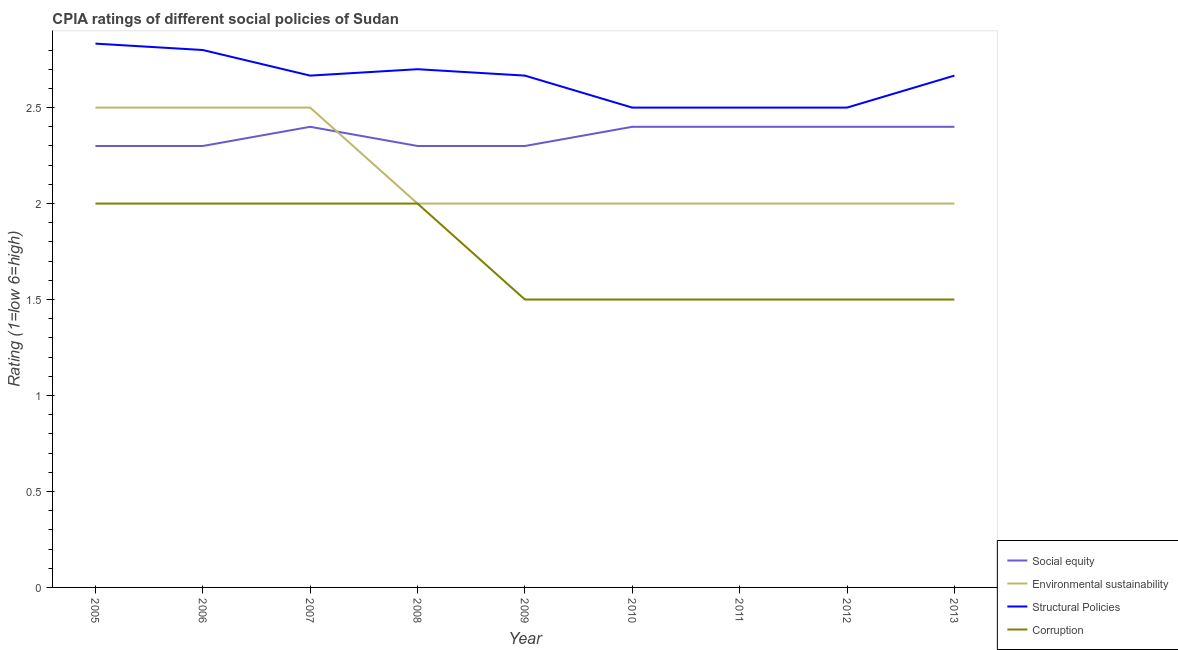How many different coloured lines are there?
Give a very brief answer. 4. What is the cpia rating of social equity in 2010?
Provide a short and direct response. 2.4. Across all years, what is the maximum cpia rating of structural policies?
Give a very brief answer. 2.83. In which year was the cpia rating of social equity maximum?
Make the answer very short. 2007. What is the total cpia rating of structural policies in the graph?
Keep it short and to the point. 23.83. What is the difference between the cpia rating of structural policies in 2007 and that in 2013?
Ensure brevity in your answer.  0. What is the difference between the cpia rating of corruption in 2009 and the cpia rating of environmental sustainability in 2013?
Offer a terse response. -0.5. What is the average cpia rating of structural policies per year?
Make the answer very short. 2.65. In the year 2010, what is the difference between the cpia rating of environmental sustainability and cpia rating of corruption?
Offer a very short reply. 0.5. What is the ratio of the cpia rating of social equity in 2007 to that in 2009?
Provide a succinct answer. 1.04. Is the difference between the cpia rating of corruption in 2011 and 2012 greater than the difference between the cpia rating of social equity in 2011 and 2012?
Keep it short and to the point. No. What is the difference between the highest and the second highest cpia rating of structural policies?
Offer a terse response. 0.03. What is the difference between the highest and the lowest cpia rating of structural policies?
Your response must be concise. 0.33. Is it the case that in every year, the sum of the cpia rating of social equity and cpia rating of environmental sustainability is greater than the cpia rating of structural policies?
Offer a very short reply. Yes. Does the graph contain grids?
Your answer should be compact. No. Where does the legend appear in the graph?
Provide a succinct answer. Bottom right. How many legend labels are there?
Your answer should be very brief. 4. What is the title of the graph?
Offer a very short reply. CPIA ratings of different social policies of Sudan. What is the label or title of the X-axis?
Provide a succinct answer. Year. What is the Rating (1=low 6=high) of Social equity in 2005?
Keep it short and to the point. 2.3. What is the Rating (1=low 6=high) in Environmental sustainability in 2005?
Your answer should be compact. 2.5. What is the Rating (1=low 6=high) of Structural Policies in 2005?
Your answer should be compact. 2.83. What is the Rating (1=low 6=high) of Structural Policies in 2006?
Make the answer very short. 2.8. What is the Rating (1=low 6=high) of Environmental sustainability in 2007?
Give a very brief answer. 2.5. What is the Rating (1=low 6=high) of Structural Policies in 2007?
Offer a very short reply. 2.67. What is the Rating (1=low 6=high) of Social equity in 2009?
Offer a terse response. 2.3. What is the Rating (1=low 6=high) in Structural Policies in 2009?
Your answer should be compact. 2.67. What is the Rating (1=low 6=high) in Social equity in 2010?
Provide a succinct answer. 2.4. What is the Rating (1=low 6=high) of Environmental sustainability in 2010?
Your answer should be compact. 2. What is the Rating (1=low 6=high) of Corruption in 2010?
Your answer should be compact. 1.5. What is the Rating (1=low 6=high) of Structural Policies in 2011?
Your answer should be very brief. 2.5. What is the Rating (1=low 6=high) of Corruption in 2011?
Make the answer very short. 1.5. What is the Rating (1=low 6=high) in Environmental sustainability in 2012?
Offer a terse response. 2. What is the Rating (1=low 6=high) of Structural Policies in 2012?
Your answer should be very brief. 2.5. What is the Rating (1=low 6=high) of Social equity in 2013?
Give a very brief answer. 2.4. What is the Rating (1=low 6=high) of Structural Policies in 2013?
Provide a succinct answer. 2.67. Across all years, what is the maximum Rating (1=low 6=high) in Structural Policies?
Make the answer very short. 2.83. Across all years, what is the maximum Rating (1=low 6=high) in Corruption?
Keep it short and to the point. 2. Across all years, what is the minimum Rating (1=low 6=high) of Social equity?
Offer a terse response. 2.3. Across all years, what is the minimum Rating (1=low 6=high) in Corruption?
Offer a terse response. 1.5. What is the total Rating (1=low 6=high) in Social equity in the graph?
Provide a short and direct response. 21.2. What is the total Rating (1=low 6=high) of Environmental sustainability in the graph?
Give a very brief answer. 19.5. What is the total Rating (1=low 6=high) in Structural Policies in the graph?
Make the answer very short. 23.83. What is the difference between the Rating (1=low 6=high) of Social equity in 2005 and that in 2006?
Your answer should be very brief. 0. What is the difference between the Rating (1=low 6=high) of Structural Policies in 2005 and that in 2006?
Your answer should be very brief. 0.03. What is the difference between the Rating (1=low 6=high) of Corruption in 2005 and that in 2006?
Give a very brief answer. 0. What is the difference between the Rating (1=low 6=high) in Structural Policies in 2005 and that in 2007?
Your answer should be very brief. 0.17. What is the difference between the Rating (1=low 6=high) of Social equity in 2005 and that in 2008?
Your answer should be compact. 0. What is the difference between the Rating (1=low 6=high) of Environmental sustainability in 2005 and that in 2008?
Give a very brief answer. 0.5. What is the difference between the Rating (1=low 6=high) in Structural Policies in 2005 and that in 2008?
Your response must be concise. 0.13. What is the difference between the Rating (1=low 6=high) of Social equity in 2005 and that in 2009?
Provide a short and direct response. 0. What is the difference between the Rating (1=low 6=high) in Social equity in 2005 and that in 2010?
Make the answer very short. -0.1. What is the difference between the Rating (1=low 6=high) of Structural Policies in 2005 and that in 2010?
Your response must be concise. 0.33. What is the difference between the Rating (1=low 6=high) of Corruption in 2005 and that in 2010?
Ensure brevity in your answer.  0.5. What is the difference between the Rating (1=low 6=high) in Corruption in 2005 and that in 2011?
Ensure brevity in your answer.  0.5. What is the difference between the Rating (1=low 6=high) of Corruption in 2005 and that in 2012?
Give a very brief answer. 0.5. What is the difference between the Rating (1=low 6=high) in Social equity in 2005 and that in 2013?
Your answer should be very brief. -0.1. What is the difference between the Rating (1=low 6=high) in Corruption in 2005 and that in 2013?
Your answer should be compact. 0.5. What is the difference between the Rating (1=low 6=high) in Social equity in 2006 and that in 2007?
Ensure brevity in your answer.  -0.1. What is the difference between the Rating (1=low 6=high) in Structural Policies in 2006 and that in 2007?
Your answer should be very brief. 0.13. What is the difference between the Rating (1=low 6=high) in Corruption in 2006 and that in 2007?
Offer a very short reply. 0. What is the difference between the Rating (1=low 6=high) of Social equity in 2006 and that in 2008?
Your answer should be compact. 0. What is the difference between the Rating (1=low 6=high) in Environmental sustainability in 2006 and that in 2008?
Your answer should be very brief. 0.5. What is the difference between the Rating (1=low 6=high) of Structural Policies in 2006 and that in 2008?
Offer a terse response. 0.1. What is the difference between the Rating (1=low 6=high) of Corruption in 2006 and that in 2008?
Your response must be concise. 0. What is the difference between the Rating (1=low 6=high) in Structural Policies in 2006 and that in 2009?
Your answer should be very brief. 0.13. What is the difference between the Rating (1=low 6=high) of Structural Policies in 2006 and that in 2012?
Provide a short and direct response. 0.3. What is the difference between the Rating (1=low 6=high) of Corruption in 2006 and that in 2012?
Ensure brevity in your answer.  0.5. What is the difference between the Rating (1=low 6=high) of Social equity in 2006 and that in 2013?
Provide a short and direct response. -0.1. What is the difference between the Rating (1=low 6=high) in Environmental sustainability in 2006 and that in 2013?
Offer a very short reply. 0.5. What is the difference between the Rating (1=low 6=high) in Structural Policies in 2006 and that in 2013?
Your response must be concise. 0.13. What is the difference between the Rating (1=low 6=high) in Corruption in 2006 and that in 2013?
Offer a very short reply. 0.5. What is the difference between the Rating (1=low 6=high) of Social equity in 2007 and that in 2008?
Offer a very short reply. 0.1. What is the difference between the Rating (1=low 6=high) in Structural Policies in 2007 and that in 2008?
Your response must be concise. -0.03. What is the difference between the Rating (1=low 6=high) of Corruption in 2007 and that in 2008?
Make the answer very short. 0. What is the difference between the Rating (1=low 6=high) in Social equity in 2007 and that in 2009?
Keep it short and to the point. 0.1. What is the difference between the Rating (1=low 6=high) of Environmental sustainability in 2007 and that in 2009?
Offer a very short reply. 0.5. What is the difference between the Rating (1=low 6=high) of Structural Policies in 2007 and that in 2009?
Offer a very short reply. 0. What is the difference between the Rating (1=low 6=high) of Social equity in 2007 and that in 2010?
Give a very brief answer. 0. What is the difference between the Rating (1=low 6=high) of Corruption in 2007 and that in 2010?
Make the answer very short. 0.5. What is the difference between the Rating (1=low 6=high) of Corruption in 2007 and that in 2012?
Keep it short and to the point. 0.5. What is the difference between the Rating (1=low 6=high) of Structural Policies in 2007 and that in 2013?
Offer a terse response. 0. What is the difference between the Rating (1=low 6=high) in Corruption in 2007 and that in 2013?
Offer a terse response. 0.5. What is the difference between the Rating (1=low 6=high) of Environmental sustainability in 2008 and that in 2009?
Your answer should be compact. 0. What is the difference between the Rating (1=low 6=high) in Corruption in 2008 and that in 2009?
Keep it short and to the point. 0.5. What is the difference between the Rating (1=low 6=high) of Social equity in 2008 and that in 2010?
Provide a succinct answer. -0.1. What is the difference between the Rating (1=low 6=high) of Structural Policies in 2008 and that in 2010?
Offer a terse response. 0.2. What is the difference between the Rating (1=low 6=high) in Corruption in 2008 and that in 2010?
Make the answer very short. 0.5. What is the difference between the Rating (1=low 6=high) in Social equity in 2008 and that in 2011?
Offer a very short reply. -0.1. What is the difference between the Rating (1=low 6=high) of Social equity in 2008 and that in 2012?
Your answer should be very brief. -0.1. What is the difference between the Rating (1=low 6=high) in Environmental sustainability in 2008 and that in 2012?
Your response must be concise. 0. What is the difference between the Rating (1=low 6=high) of Structural Policies in 2008 and that in 2012?
Your response must be concise. 0.2. What is the difference between the Rating (1=low 6=high) of Corruption in 2008 and that in 2012?
Your response must be concise. 0.5. What is the difference between the Rating (1=low 6=high) in Environmental sustainability in 2008 and that in 2013?
Your response must be concise. 0. What is the difference between the Rating (1=low 6=high) in Social equity in 2009 and that in 2010?
Give a very brief answer. -0.1. What is the difference between the Rating (1=low 6=high) in Social equity in 2009 and that in 2011?
Give a very brief answer. -0.1. What is the difference between the Rating (1=low 6=high) in Corruption in 2009 and that in 2011?
Your answer should be compact. 0. What is the difference between the Rating (1=low 6=high) of Environmental sustainability in 2009 and that in 2012?
Make the answer very short. 0. What is the difference between the Rating (1=low 6=high) of Corruption in 2009 and that in 2012?
Offer a very short reply. 0. What is the difference between the Rating (1=low 6=high) in Social equity in 2009 and that in 2013?
Your answer should be very brief. -0.1. What is the difference between the Rating (1=low 6=high) of Environmental sustainability in 2009 and that in 2013?
Keep it short and to the point. 0. What is the difference between the Rating (1=low 6=high) of Structural Policies in 2009 and that in 2013?
Keep it short and to the point. 0. What is the difference between the Rating (1=low 6=high) in Environmental sustainability in 2010 and that in 2011?
Make the answer very short. 0. What is the difference between the Rating (1=low 6=high) in Social equity in 2010 and that in 2012?
Provide a succinct answer. 0. What is the difference between the Rating (1=low 6=high) of Structural Policies in 2010 and that in 2012?
Offer a very short reply. 0. What is the difference between the Rating (1=low 6=high) of Structural Policies in 2010 and that in 2013?
Give a very brief answer. -0.17. What is the difference between the Rating (1=low 6=high) of Corruption in 2011 and that in 2012?
Keep it short and to the point. 0. What is the difference between the Rating (1=low 6=high) of Environmental sustainability in 2011 and that in 2013?
Your answer should be very brief. 0. What is the difference between the Rating (1=low 6=high) in Environmental sustainability in 2012 and that in 2013?
Offer a terse response. 0. What is the difference between the Rating (1=low 6=high) of Corruption in 2012 and that in 2013?
Offer a terse response. 0. What is the difference between the Rating (1=low 6=high) of Social equity in 2005 and the Rating (1=low 6=high) of Environmental sustainability in 2006?
Give a very brief answer. -0.2. What is the difference between the Rating (1=low 6=high) of Social equity in 2005 and the Rating (1=low 6=high) of Structural Policies in 2006?
Ensure brevity in your answer.  -0.5. What is the difference between the Rating (1=low 6=high) of Social equity in 2005 and the Rating (1=low 6=high) of Corruption in 2006?
Make the answer very short. 0.3. What is the difference between the Rating (1=low 6=high) of Environmental sustainability in 2005 and the Rating (1=low 6=high) of Structural Policies in 2006?
Your response must be concise. -0.3. What is the difference between the Rating (1=low 6=high) in Environmental sustainability in 2005 and the Rating (1=low 6=high) in Corruption in 2006?
Provide a short and direct response. 0.5. What is the difference between the Rating (1=low 6=high) in Social equity in 2005 and the Rating (1=low 6=high) in Structural Policies in 2007?
Offer a very short reply. -0.37. What is the difference between the Rating (1=low 6=high) in Social equity in 2005 and the Rating (1=low 6=high) in Corruption in 2007?
Offer a very short reply. 0.3. What is the difference between the Rating (1=low 6=high) of Structural Policies in 2005 and the Rating (1=low 6=high) of Corruption in 2007?
Give a very brief answer. 0.83. What is the difference between the Rating (1=low 6=high) of Social equity in 2005 and the Rating (1=low 6=high) of Environmental sustainability in 2008?
Make the answer very short. 0.3. What is the difference between the Rating (1=low 6=high) of Social equity in 2005 and the Rating (1=low 6=high) of Structural Policies in 2008?
Give a very brief answer. -0.4. What is the difference between the Rating (1=low 6=high) of Environmental sustainability in 2005 and the Rating (1=low 6=high) of Structural Policies in 2008?
Keep it short and to the point. -0.2. What is the difference between the Rating (1=low 6=high) of Social equity in 2005 and the Rating (1=low 6=high) of Structural Policies in 2009?
Provide a succinct answer. -0.37. What is the difference between the Rating (1=low 6=high) of Environmental sustainability in 2005 and the Rating (1=low 6=high) of Structural Policies in 2009?
Give a very brief answer. -0.17. What is the difference between the Rating (1=low 6=high) in Structural Policies in 2005 and the Rating (1=low 6=high) in Corruption in 2009?
Your answer should be compact. 1.33. What is the difference between the Rating (1=low 6=high) of Social equity in 2005 and the Rating (1=low 6=high) of Environmental sustainability in 2010?
Offer a very short reply. 0.3. What is the difference between the Rating (1=low 6=high) of Social equity in 2005 and the Rating (1=low 6=high) of Structural Policies in 2010?
Offer a very short reply. -0.2. What is the difference between the Rating (1=low 6=high) of Social equity in 2005 and the Rating (1=low 6=high) of Corruption in 2010?
Offer a very short reply. 0.8. What is the difference between the Rating (1=low 6=high) of Environmental sustainability in 2005 and the Rating (1=low 6=high) of Structural Policies in 2010?
Offer a terse response. 0. What is the difference between the Rating (1=low 6=high) of Environmental sustainability in 2005 and the Rating (1=low 6=high) of Corruption in 2010?
Provide a succinct answer. 1. What is the difference between the Rating (1=low 6=high) in Structural Policies in 2005 and the Rating (1=low 6=high) in Corruption in 2010?
Your answer should be compact. 1.33. What is the difference between the Rating (1=low 6=high) in Social equity in 2005 and the Rating (1=low 6=high) in Environmental sustainability in 2011?
Offer a terse response. 0.3. What is the difference between the Rating (1=low 6=high) of Environmental sustainability in 2005 and the Rating (1=low 6=high) of Structural Policies in 2011?
Offer a terse response. 0. What is the difference between the Rating (1=low 6=high) in Social equity in 2005 and the Rating (1=low 6=high) in Structural Policies in 2012?
Make the answer very short. -0.2. What is the difference between the Rating (1=low 6=high) of Social equity in 2005 and the Rating (1=low 6=high) of Corruption in 2012?
Your response must be concise. 0.8. What is the difference between the Rating (1=low 6=high) of Environmental sustainability in 2005 and the Rating (1=low 6=high) of Corruption in 2012?
Your answer should be compact. 1. What is the difference between the Rating (1=low 6=high) of Social equity in 2005 and the Rating (1=low 6=high) of Structural Policies in 2013?
Make the answer very short. -0.37. What is the difference between the Rating (1=low 6=high) of Environmental sustainability in 2005 and the Rating (1=low 6=high) of Corruption in 2013?
Your answer should be very brief. 1. What is the difference between the Rating (1=low 6=high) of Structural Policies in 2005 and the Rating (1=low 6=high) of Corruption in 2013?
Your answer should be compact. 1.33. What is the difference between the Rating (1=low 6=high) of Social equity in 2006 and the Rating (1=low 6=high) of Environmental sustainability in 2007?
Your response must be concise. -0.2. What is the difference between the Rating (1=low 6=high) of Social equity in 2006 and the Rating (1=low 6=high) of Structural Policies in 2007?
Your response must be concise. -0.37. What is the difference between the Rating (1=low 6=high) of Social equity in 2006 and the Rating (1=low 6=high) of Corruption in 2007?
Offer a very short reply. 0.3. What is the difference between the Rating (1=low 6=high) in Structural Policies in 2006 and the Rating (1=low 6=high) in Corruption in 2007?
Make the answer very short. 0.8. What is the difference between the Rating (1=low 6=high) in Social equity in 2006 and the Rating (1=low 6=high) in Structural Policies in 2008?
Provide a short and direct response. -0.4. What is the difference between the Rating (1=low 6=high) of Social equity in 2006 and the Rating (1=low 6=high) of Corruption in 2008?
Your answer should be compact. 0.3. What is the difference between the Rating (1=low 6=high) in Environmental sustainability in 2006 and the Rating (1=low 6=high) in Structural Policies in 2008?
Ensure brevity in your answer.  -0.2. What is the difference between the Rating (1=low 6=high) in Environmental sustainability in 2006 and the Rating (1=low 6=high) in Corruption in 2008?
Make the answer very short. 0.5. What is the difference between the Rating (1=low 6=high) of Social equity in 2006 and the Rating (1=low 6=high) of Structural Policies in 2009?
Provide a short and direct response. -0.37. What is the difference between the Rating (1=low 6=high) in Social equity in 2006 and the Rating (1=low 6=high) in Corruption in 2009?
Offer a very short reply. 0.8. What is the difference between the Rating (1=low 6=high) of Environmental sustainability in 2006 and the Rating (1=low 6=high) of Structural Policies in 2009?
Your response must be concise. -0.17. What is the difference between the Rating (1=low 6=high) in Environmental sustainability in 2006 and the Rating (1=low 6=high) in Corruption in 2009?
Keep it short and to the point. 1. What is the difference between the Rating (1=low 6=high) in Environmental sustainability in 2006 and the Rating (1=low 6=high) in Corruption in 2010?
Your response must be concise. 1. What is the difference between the Rating (1=low 6=high) in Social equity in 2006 and the Rating (1=low 6=high) in Structural Policies in 2011?
Ensure brevity in your answer.  -0.2. What is the difference between the Rating (1=low 6=high) in Social equity in 2006 and the Rating (1=low 6=high) in Corruption in 2011?
Provide a short and direct response. 0.8. What is the difference between the Rating (1=low 6=high) in Environmental sustainability in 2006 and the Rating (1=low 6=high) in Corruption in 2011?
Keep it short and to the point. 1. What is the difference between the Rating (1=low 6=high) of Structural Policies in 2006 and the Rating (1=low 6=high) of Corruption in 2011?
Your answer should be compact. 1.3. What is the difference between the Rating (1=low 6=high) of Social equity in 2006 and the Rating (1=low 6=high) of Corruption in 2012?
Your answer should be very brief. 0.8. What is the difference between the Rating (1=low 6=high) in Social equity in 2006 and the Rating (1=low 6=high) in Environmental sustainability in 2013?
Your answer should be very brief. 0.3. What is the difference between the Rating (1=low 6=high) in Social equity in 2006 and the Rating (1=low 6=high) in Structural Policies in 2013?
Your answer should be compact. -0.37. What is the difference between the Rating (1=low 6=high) in Environmental sustainability in 2006 and the Rating (1=low 6=high) in Corruption in 2013?
Offer a terse response. 1. What is the difference between the Rating (1=low 6=high) of Social equity in 2007 and the Rating (1=low 6=high) of Environmental sustainability in 2008?
Your answer should be compact. 0.4. What is the difference between the Rating (1=low 6=high) of Social equity in 2007 and the Rating (1=low 6=high) of Structural Policies in 2008?
Your response must be concise. -0.3. What is the difference between the Rating (1=low 6=high) in Social equity in 2007 and the Rating (1=low 6=high) in Corruption in 2008?
Offer a very short reply. 0.4. What is the difference between the Rating (1=low 6=high) in Environmental sustainability in 2007 and the Rating (1=low 6=high) in Structural Policies in 2008?
Offer a terse response. -0.2. What is the difference between the Rating (1=low 6=high) in Environmental sustainability in 2007 and the Rating (1=low 6=high) in Corruption in 2008?
Make the answer very short. 0.5. What is the difference between the Rating (1=low 6=high) in Social equity in 2007 and the Rating (1=low 6=high) in Structural Policies in 2009?
Keep it short and to the point. -0.27. What is the difference between the Rating (1=low 6=high) in Environmental sustainability in 2007 and the Rating (1=low 6=high) in Corruption in 2009?
Keep it short and to the point. 1. What is the difference between the Rating (1=low 6=high) of Structural Policies in 2007 and the Rating (1=low 6=high) of Corruption in 2009?
Make the answer very short. 1.17. What is the difference between the Rating (1=low 6=high) of Social equity in 2007 and the Rating (1=low 6=high) of Structural Policies in 2010?
Provide a succinct answer. -0.1. What is the difference between the Rating (1=low 6=high) in Environmental sustainability in 2007 and the Rating (1=low 6=high) in Structural Policies in 2010?
Ensure brevity in your answer.  0. What is the difference between the Rating (1=low 6=high) of Social equity in 2007 and the Rating (1=low 6=high) of Environmental sustainability in 2011?
Your response must be concise. 0.4. What is the difference between the Rating (1=low 6=high) in Environmental sustainability in 2007 and the Rating (1=low 6=high) in Structural Policies in 2011?
Make the answer very short. 0. What is the difference between the Rating (1=low 6=high) in Environmental sustainability in 2007 and the Rating (1=low 6=high) in Corruption in 2011?
Provide a short and direct response. 1. What is the difference between the Rating (1=low 6=high) in Structural Policies in 2007 and the Rating (1=low 6=high) in Corruption in 2011?
Offer a very short reply. 1.17. What is the difference between the Rating (1=low 6=high) of Environmental sustainability in 2007 and the Rating (1=low 6=high) of Structural Policies in 2012?
Keep it short and to the point. 0. What is the difference between the Rating (1=low 6=high) in Environmental sustainability in 2007 and the Rating (1=low 6=high) in Corruption in 2012?
Make the answer very short. 1. What is the difference between the Rating (1=low 6=high) of Structural Policies in 2007 and the Rating (1=low 6=high) of Corruption in 2012?
Offer a very short reply. 1.17. What is the difference between the Rating (1=low 6=high) in Social equity in 2007 and the Rating (1=low 6=high) in Environmental sustainability in 2013?
Make the answer very short. 0.4. What is the difference between the Rating (1=low 6=high) in Social equity in 2007 and the Rating (1=low 6=high) in Structural Policies in 2013?
Your answer should be compact. -0.27. What is the difference between the Rating (1=low 6=high) in Environmental sustainability in 2007 and the Rating (1=low 6=high) in Structural Policies in 2013?
Your response must be concise. -0.17. What is the difference between the Rating (1=low 6=high) in Environmental sustainability in 2007 and the Rating (1=low 6=high) in Corruption in 2013?
Your response must be concise. 1. What is the difference between the Rating (1=low 6=high) in Social equity in 2008 and the Rating (1=low 6=high) in Structural Policies in 2009?
Your response must be concise. -0.37. What is the difference between the Rating (1=low 6=high) in Social equity in 2008 and the Rating (1=low 6=high) in Corruption in 2009?
Make the answer very short. 0.8. What is the difference between the Rating (1=low 6=high) in Environmental sustainability in 2008 and the Rating (1=low 6=high) in Structural Policies in 2009?
Your answer should be compact. -0.67. What is the difference between the Rating (1=low 6=high) of Environmental sustainability in 2008 and the Rating (1=low 6=high) of Corruption in 2009?
Offer a very short reply. 0.5. What is the difference between the Rating (1=low 6=high) of Structural Policies in 2008 and the Rating (1=low 6=high) of Corruption in 2009?
Give a very brief answer. 1.2. What is the difference between the Rating (1=low 6=high) of Social equity in 2008 and the Rating (1=low 6=high) of Environmental sustainability in 2010?
Keep it short and to the point. 0.3. What is the difference between the Rating (1=low 6=high) of Social equity in 2008 and the Rating (1=low 6=high) of Structural Policies in 2010?
Give a very brief answer. -0.2. What is the difference between the Rating (1=low 6=high) of Environmental sustainability in 2008 and the Rating (1=low 6=high) of Structural Policies in 2010?
Give a very brief answer. -0.5. What is the difference between the Rating (1=low 6=high) of Environmental sustainability in 2008 and the Rating (1=low 6=high) of Corruption in 2010?
Your answer should be compact. 0.5. What is the difference between the Rating (1=low 6=high) of Structural Policies in 2008 and the Rating (1=low 6=high) of Corruption in 2010?
Offer a very short reply. 1.2. What is the difference between the Rating (1=low 6=high) of Social equity in 2008 and the Rating (1=low 6=high) of Environmental sustainability in 2011?
Your answer should be compact. 0.3. What is the difference between the Rating (1=low 6=high) in Environmental sustainability in 2008 and the Rating (1=low 6=high) in Structural Policies in 2011?
Your answer should be compact. -0.5. What is the difference between the Rating (1=low 6=high) of Environmental sustainability in 2008 and the Rating (1=low 6=high) of Corruption in 2011?
Your answer should be compact. 0.5. What is the difference between the Rating (1=low 6=high) in Structural Policies in 2008 and the Rating (1=low 6=high) in Corruption in 2011?
Your answer should be compact. 1.2. What is the difference between the Rating (1=low 6=high) in Social equity in 2008 and the Rating (1=low 6=high) in Structural Policies in 2012?
Make the answer very short. -0.2. What is the difference between the Rating (1=low 6=high) in Environmental sustainability in 2008 and the Rating (1=low 6=high) in Structural Policies in 2012?
Provide a succinct answer. -0.5. What is the difference between the Rating (1=low 6=high) in Environmental sustainability in 2008 and the Rating (1=low 6=high) in Corruption in 2012?
Your answer should be compact. 0.5. What is the difference between the Rating (1=low 6=high) in Social equity in 2008 and the Rating (1=low 6=high) in Environmental sustainability in 2013?
Your answer should be compact. 0.3. What is the difference between the Rating (1=low 6=high) of Social equity in 2008 and the Rating (1=low 6=high) of Structural Policies in 2013?
Give a very brief answer. -0.37. What is the difference between the Rating (1=low 6=high) in Environmental sustainability in 2008 and the Rating (1=low 6=high) in Corruption in 2013?
Your answer should be compact. 0.5. What is the difference between the Rating (1=low 6=high) in Structural Policies in 2008 and the Rating (1=low 6=high) in Corruption in 2013?
Ensure brevity in your answer.  1.2. What is the difference between the Rating (1=low 6=high) in Social equity in 2009 and the Rating (1=low 6=high) in Structural Policies in 2010?
Your answer should be very brief. -0.2. What is the difference between the Rating (1=low 6=high) in Social equity in 2009 and the Rating (1=low 6=high) in Corruption in 2010?
Provide a succinct answer. 0.8. What is the difference between the Rating (1=low 6=high) in Environmental sustainability in 2009 and the Rating (1=low 6=high) in Structural Policies in 2010?
Keep it short and to the point. -0.5. What is the difference between the Rating (1=low 6=high) of Environmental sustainability in 2009 and the Rating (1=low 6=high) of Corruption in 2010?
Provide a succinct answer. 0.5. What is the difference between the Rating (1=low 6=high) of Structural Policies in 2009 and the Rating (1=low 6=high) of Corruption in 2010?
Make the answer very short. 1.17. What is the difference between the Rating (1=low 6=high) in Social equity in 2009 and the Rating (1=low 6=high) in Environmental sustainability in 2011?
Give a very brief answer. 0.3. What is the difference between the Rating (1=low 6=high) in Social equity in 2009 and the Rating (1=low 6=high) in Structural Policies in 2011?
Your response must be concise. -0.2. What is the difference between the Rating (1=low 6=high) of Social equity in 2009 and the Rating (1=low 6=high) of Corruption in 2011?
Keep it short and to the point. 0.8. What is the difference between the Rating (1=low 6=high) of Environmental sustainability in 2009 and the Rating (1=low 6=high) of Corruption in 2011?
Your answer should be compact. 0.5. What is the difference between the Rating (1=low 6=high) of Structural Policies in 2009 and the Rating (1=low 6=high) of Corruption in 2011?
Keep it short and to the point. 1.17. What is the difference between the Rating (1=low 6=high) in Social equity in 2009 and the Rating (1=low 6=high) in Structural Policies in 2012?
Provide a short and direct response. -0.2. What is the difference between the Rating (1=low 6=high) of Environmental sustainability in 2009 and the Rating (1=low 6=high) of Corruption in 2012?
Provide a short and direct response. 0.5. What is the difference between the Rating (1=low 6=high) in Structural Policies in 2009 and the Rating (1=low 6=high) in Corruption in 2012?
Your response must be concise. 1.17. What is the difference between the Rating (1=low 6=high) in Social equity in 2009 and the Rating (1=low 6=high) in Structural Policies in 2013?
Your answer should be compact. -0.37. What is the difference between the Rating (1=low 6=high) of Environmental sustainability in 2009 and the Rating (1=low 6=high) of Structural Policies in 2013?
Offer a very short reply. -0.67. What is the difference between the Rating (1=low 6=high) of Social equity in 2010 and the Rating (1=low 6=high) of Structural Policies in 2011?
Your response must be concise. -0.1. What is the difference between the Rating (1=low 6=high) of Structural Policies in 2010 and the Rating (1=low 6=high) of Corruption in 2011?
Keep it short and to the point. 1. What is the difference between the Rating (1=low 6=high) in Social equity in 2010 and the Rating (1=low 6=high) in Structural Policies in 2012?
Your answer should be very brief. -0.1. What is the difference between the Rating (1=low 6=high) in Environmental sustainability in 2010 and the Rating (1=low 6=high) in Corruption in 2012?
Your response must be concise. 0.5. What is the difference between the Rating (1=low 6=high) of Structural Policies in 2010 and the Rating (1=low 6=high) of Corruption in 2012?
Provide a short and direct response. 1. What is the difference between the Rating (1=low 6=high) of Social equity in 2010 and the Rating (1=low 6=high) of Environmental sustainability in 2013?
Provide a short and direct response. 0.4. What is the difference between the Rating (1=low 6=high) of Social equity in 2010 and the Rating (1=low 6=high) of Structural Policies in 2013?
Ensure brevity in your answer.  -0.27. What is the difference between the Rating (1=low 6=high) of Environmental sustainability in 2010 and the Rating (1=low 6=high) of Structural Policies in 2013?
Your answer should be compact. -0.67. What is the difference between the Rating (1=low 6=high) of Social equity in 2011 and the Rating (1=low 6=high) of Structural Policies in 2012?
Give a very brief answer. -0.1. What is the difference between the Rating (1=low 6=high) of Environmental sustainability in 2011 and the Rating (1=low 6=high) of Corruption in 2012?
Your answer should be compact. 0.5. What is the difference between the Rating (1=low 6=high) of Social equity in 2011 and the Rating (1=low 6=high) of Structural Policies in 2013?
Provide a short and direct response. -0.27. What is the difference between the Rating (1=low 6=high) in Social equity in 2011 and the Rating (1=low 6=high) in Corruption in 2013?
Your answer should be compact. 0.9. What is the difference between the Rating (1=low 6=high) in Environmental sustainability in 2011 and the Rating (1=low 6=high) in Structural Policies in 2013?
Offer a terse response. -0.67. What is the difference between the Rating (1=low 6=high) in Structural Policies in 2011 and the Rating (1=low 6=high) in Corruption in 2013?
Offer a very short reply. 1. What is the difference between the Rating (1=low 6=high) in Social equity in 2012 and the Rating (1=low 6=high) in Structural Policies in 2013?
Offer a terse response. -0.27. What is the difference between the Rating (1=low 6=high) of Environmental sustainability in 2012 and the Rating (1=low 6=high) of Corruption in 2013?
Your answer should be compact. 0.5. What is the difference between the Rating (1=low 6=high) of Structural Policies in 2012 and the Rating (1=low 6=high) of Corruption in 2013?
Provide a succinct answer. 1. What is the average Rating (1=low 6=high) of Social equity per year?
Provide a succinct answer. 2.36. What is the average Rating (1=low 6=high) of Environmental sustainability per year?
Your answer should be compact. 2.17. What is the average Rating (1=low 6=high) in Structural Policies per year?
Your answer should be compact. 2.65. What is the average Rating (1=low 6=high) of Corruption per year?
Provide a short and direct response. 1.72. In the year 2005, what is the difference between the Rating (1=low 6=high) in Social equity and Rating (1=low 6=high) in Structural Policies?
Offer a very short reply. -0.53. In the year 2005, what is the difference between the Rating (1=low 6=high) of Environmental sustainability and Rating (1=low 6=high) of Structural Policies?
Offer a very short reply. -0.33. In the year 2006, what is the difference between the Rating (1=low 6=high) in Social equity and Rating (1=low 6=high) in Structural Policies?
Offer a very short reply. -0.5. In the year 2006, what is the difference between the Rating (1=low 6=high) in Environmental sustainability and Rating (1=low 6=high) in Structural Policies?
Provide a succinct answer. -0.3. In the year 2007, what is the difference between the Rating (1=low 6=high) in Social equity and Rating (1=low 6=high) in Structural Policies?
Your response must be concise. -0.27. In the year 2007, what is the difference between the Rating (1=low 6=high) in Social equity and Rating (1=low 6=high) in Corruption?
Provide a succinct answer. 0.4. In the year 2007, what is the difference between the Rating (1=low 6=high) of Environmental sustainability and Rating (1=low 6=high) of Structural Policies?
Your response must be concise. -0.17. In the year 2007, what is the difference between the Rating (1=low 6=high) in Structural Policies and Rating (1=low 6=high) in Corruption?
Offer a terse response. 0.67. In the year 2008, what is the difference between the Rating (1=low 6=high) of Social equity and Rating (1=low 6=high) of Environmental sustainability?
Your answer should be very brief. 0.3. In the year 2008, what is the difference between the Rating (1=low 6=high) in Social equity and Rating (1=low 6=high) in Structural Policies?
Provide a short and direct response. -0.4. In the year 2008, what is the difference between the Rating (1=low 6=high) of Environmental sustainability and Rating (1=low 6=high) of Corruption?
Ensure brevity in your answer.  0. In the year 2009, what is the difference between the Rating (1=low 6=high) in Social equity and Rating (1=low 6=high) in Structural Policies?
Give a very brief answer. -0.37. In the year 2009, what is the difference between the Rating (1=low 6=high) in Environmental sustainability and Rating (1=low 6=high) in Structural Policies?
Your answer should be compact. -0.67. In the year 2009, what is the difference between the Rating (1=low 6=high) of Environmental sustainability and Rating (1=low 6=high) of Corruption?
Provide a short and direct response. 0.5. In the year 2009, what is the difference between the Rating (1=low 6=high) in Structural Policies and Rating (1=low 6=high) in Corruption?
Offer a very short reply. 1.17. In the year 2010, what is the difference between the Rating (1=low 6=high) in Social equity and Rating (1=low 6=high) in Environmental sustainability?
Provide a short and direct response. 0.4. In the year 2010, what is the difference between the Rating (1=low 6=high) in Social equity and Rating (1=low 6=high) in Structural Policies?
Give a very brief answer. -0.1. In the year 2010, what is the difference between the Rating (1=low 6=high) in Social equity and Rating (1=low 6=high) in Corruption?
Your answer should be compact. 0.9. In the year 2011, what is the difference between the Rating (1=low 6=high) of Social equity and Rating (1=low 6=high) of Environmental sustainability?
Offer a terse response. 0.4. In the year 2012, what is the difference between the Rating (1=low 6=high) of Social equity and Rating (1=low 6=high) of Structural Policies?
Your answer should be very brief. -0.1. In the year 2012, what is the difference between the Rating (1=low 6=high) of Social equity and Rating (1=low 6=high) of Corruption?
Your answer should be very brief. 0.9. In the year 2012, what is the difference between the Rating (1=low 6=high) in Environmental sustainability and Rating (1=low 6=high) in Structural Policies?
Keep it short and to the point. -0.5. In the year 2012, what is the difference between the Rating (1=low 6=high) of Environmental sustainability and Rating (1=low 6=high) of Corruption?
Keep it short and to the point. 0.5. In the year 2013, what is the difference between the Rating (1=low 6=high) in Social equity and Rating (1=low 6=high) in Environmental sustainability?
Offer a very short reply. 0.4. In the year 2013, what is the difference between the Rating (1=low 6=high) of Social equity and Rating (1=low 6=high) of Structural Policies?
Your response must be concise. -0.27. In the year 2013, what is the difference between the Rating (1=low 6=high) of Social equity and Rating (1=low 6=high) of Corruption?
Keep it short and to the point. 0.9. In the year 2013, what is the difference between the Rating (1=low 6=high) in Environmental sustainability and Rating (1=low 6=high) in Structural Policies?
Keep it short and to the point. -0.67. In the year 2013, what is the difference between the Rating (1=low 6=high) of Structural Policies and Rating (1=low 6=high) of Corruption?
Your answer should be very brief. 1.17. What is the ratio of the Rating (1=low 6=high) of Structural Policies in 2005 to that in 2006?
Keep it short and to the point. 1.01. What is the ratio of the Rating (1=low 6=high) in Corruption in 2005 to that in 2006?
Your response must be concise. 1. What is the ratio of the Rating (1=low 6=high) of Social equity in 2005 to that in 2007?
Give a very brief answer. 0.96. What is the ratio of the Rating (1=low 6=high) of Environmental sustainability in 2005 to that in 2007?
Make the answer very short. 1. What is the ratio of the Rating (1=low 6=high) of Corruption in 2005 to that in 2007?
Offer a terse response. 1. What is the ratio of the Rating (1=low 6=high) in Environmental sustainability in 2005 to that in 2008?
Provide a succinct answer. 1.25. What is the ratio of the Rating (1=low 6=high) of Structural Policies in 2005 to that in 2008?
Your answer should be compact. 1.05. What is the ratio of the Rating (1=low 6=high) of Structural Policies in 2005 to that in 2009?
Keep it short and to the point. 1.06. What is the ratio of the Rating (1=low 6=high) in Environmental sustainability in 2005 to that in 2010?
Your answer should be compact. 1.25. What is the ratio of the Rating (1=low 6=high) of Structural Policies in 2005 to that in 2010?
Provide a succinct answer. 1.13. What is the ratio of the Rating (1=low 6=high) of Corruption in 2005 to that in 2010?
Your answer should be compact. 1.33. What is the ratio of the Rating (1=low 6=high) of Social equity in 2005 to that in 2011?
Make the answer very short. 0.96. What is the ratio of the Rating (1=low 6=high) in Structural Policies in 2005 to that in 2011?
Ensure brevity in your answer.  1.13. What is the ratio of the Rating (1=low 6=high) of Corruption in 2005 to that in 2011?
Offer a terse response. 1.33. What is the ratio of the Rating (1=low 6=high) in Structural Policies in 2005 to that in 2012?
Provide a short and direct response. 1.13. What is the ratio of the Rating (1=low 6=high) of Corruption in 2005 to that in 2012?
Offer a very short reply. 1.33. What is the ratio of the Rating (1=low 6=high) in Environmental sustainability in 2005 to that in 2013?
Make the answer very short. 1.25. What is the ratio of the Rating (1=low 6=high) in Social equity in 2006 to that in 2007?
Make the answer very short. 0.96. What is the ratio of the Rating (1=low 6=high) in Structural Policies in 2006 to that in 2007?
Give a very brief answer. 1.05. What is the ratio of the Rating (1=low 6=high) in Corruption in 2006 to that in 2007?
Ensure brevity in your answer.  1. What is the ratio of the Rating (1=low 6=high) in Social equity in 2006 to that in 2008?
Give a very brief answer. 1. What is the ratio of the Rating (1=low 6=high) of Environmental sustainability in 2006 to that in 2008?
Provide a succinct answer. 1.25. What is the ratio of the Rating (1=low 6=high) of Structural Policies in 2006 to that in 2008?
Offer a very short reply. 1.04. What is the ratio of the Rating (1=low 6=high) of Social equity in 2006 to that in 2009?
Offer a terse response. 1. What is the ratio of the Rating (1=low 6=high) of Environmental sustainability in 2006 to that in 2009?
Your answer should be compact. 1.25. What is the ratio of the Rating (1=low 6=high) of Structural Policies in 2006 to that in 2009?
Provide a succinct answer. 1.05. What is the ratio of the Rating (1=low 6=high) in Social equity in 2006 to that in 2010?
Ensure brevity in your answer.  0.96. What is the ratio of the Rating (1=low 6=high) of Structural Policies in 2006 to that in 2010?
Your response must be concise. 1.12. What is the ratio of the Rating (1=low 6=high) in Corruption in 2006 to that in 2010?
Provide a succinct answer. 1.33. What is the ratio of the Rating (1=low 6=high) in Social equity in 2006 to that in 2011?
Provide a succinct answer. 0.96. What is the ratio of the Rating (1=low 6=high) of Structural Policies in 2006 to that in 2011?
Offer a terse response. 1.12. What is the ratio of the Rating (1=low 6=high) in Corruption in 2006 to that in 2011?
Provide a succinct answer. 1.33. What is the ratio of the Rating (1=low 6=high) of Structural Policies in 2006 to that in 2012?
Ensure brevity in your answer.  1.12. What is the ratio of the Rating (1=low 6=high) in Corruption in 2006 to that in 2012?
Make the answer very short. 1.33. What is the ratio of the Rating (1=low 6=high) of Environmental sustainability in 2006 to that in 2013?
Keep it short and to the point. 1.25. What is the ratio of the Rating (1=low 6=high) in Structural Policies in 2006 to that in 2013?
Make the answer very short. 1.05. What is the ratio of the Rating (1=low 6=high) in Corruption in 2006 to that in 2013?
Your answer should be very brief. 1.33. What is the ratio of the Rating (1=low 6=high) in Social equity in 2007 to that in 2008?
Give a very brief answer. 1.04. What is the ratio of the Rating (1=low 6=high) in Social equity in 2007 to that in 2009?
Provide a succinct answer. 1.04. What is the ratio of the Rating (1=low 6=high) in Structural Policies in 2007 to that in 2009?
Give a very brief answer. 1. What is the ratio of the Rating (1=low 6=high) of Corruption in 2007 to that in 2009?
Offer a terse response. 1.33. What is the ratio of the Rating (1=low 6=high) in Environmental sustainability in 2007 to that in 2010?
Your answer should be compact. 1.25. What is the ratio of the Rating (1=low 6=high) of Structural Policies in 2007 to that in 2010?
Your answer should be very brief. 1.07. What is the ratio of the Rating (1=low 6=high) of Structural Policies in 2007 to that in 2011?
Your response must be concise. 1.07. What is the ratio of the Rating (1=low 6=high) of Corruption in 2007 to that in 2011?
Your answer should be compact. 1.33. What is the ratio of the Rating (1=low 6=high) of Social equity in 2007 to that in 2012?
Your answer should be very brief. 1. What is the ratio of the Rating (1=low 6=high) of Environmental sustainability in 2007 to that in 2012?
Provide a short and direct response. 1.25. What is the ratio of the Rating (1=low 6=high) in Structural Policies in 2007 to that in 2012?
Offer a very short reply. 1.07. What is the ratio of the Rating (1=low 6=high) in Corruption in 2007 to that in 2012?
Your answer should be very brief. 1.33. What is the ratio of the Rating (1=low 6=high) of Social equity in 2007 to that in 2013?
Your answer should be compact. 1. What is the ratio of the Rating (1=low 6=high) in Environmental sustainability in 2007 to that in 2013?
Provide a succinct answer. 1.25. What is the ratio of the Rating (1=low 6=high) of Structural Policies in 2007 to that in 2013?
Provide a succinct answer. 1. What is the ratio of the Rating (1=low 6=high) in Environmental sustainability in 2008 to that in 2009?
Your answer should be very brief. 1. What is the ratio of the Rating (1=low 6=high) in Structural Policies in 2008 to that in 2009?
Provide a short and direct response. 1.01. What is the ratio of the Rating (1=low 6=high) in Social equity in 2008 to that in 2010?
Make the answer very short. 0.96. What is the ratio of the Rating (1=low 6=high) of Environmental sustainability in 2008 to that in 2010?
Offer a very short reply. 1. What is the ratio of the Rating (1=low 6=high) of Environmental sustainability in 2008 to that in 2011?
Your answer should be very brief. 1. What is the ratio of the Rating (1=low 6=high) of Structural Policies in 2008 to that in 2011?
Your answer should be compact. 1.08. What is the ratio of the Rating (1=low 6=high) in Corruption in 2008 to that in 2011?
Your answer should be compact. 1.33. What is the ratio of the Rating (1=low 6=high) of Social equity in 2008 to that in 2012?
Offer a terse response. 0.96. What is the ratio of the Rating (1=low 6=high) in Environmental sustainability in 2008 to that in 2012?
Offer a terse response. 1. What is the ratio of the Rating (1=low 6=high) in Structural Policies in 2008 to that in 2012?
Make the answer very short. 1.08. What is the ratio of the Rating (1=low 6=high) of Corruption in 2008 to that in 2012?
Keep it short and to the point. 1.33. What is the ratio of the Rating (1=low 6=high) of Social equity in 2008 to that in 2013?
Make the answer very short. 0.96. What is the ratio of the Rating (1=low 6=high) in Structural Policies in 2008 to that in 2013?
Ensure brevity in your answer.  1.01. What is the ratio of the Rating (1=low 6=high) of Structural Policies in 2009 to that in 2010?
Keep it short and to the point. 1.07. What is the ratio of the Rating (1=low 6=high) in Corruption in 2009 to that in 2010?
Make the answer very short. 1. What is the ratio of the Rating (1=low 6=high) of Social equity in 2009 to that in 2011?
Offer a very short reply. 0.96. What is the ratio of the Rating (1=low 6=high) in Environmental sustainability in 2009 to that in 2011?
Keep it short and to the point. 1. What is the ratio of the Rating (1=low 6=high) of Structural Policies in 2009 to that in 2011?
Provide a short and direct response. 1.07. What is the ratio of the Rating (1=low 6=high) in Environmental sustainability in 2009 to that in 2012?
Offer a very short reply. 1. What is the ratio of the Rating (1=low 6=high) of Structural Policies in 2009 to that in 2012?
Keep it short and to the point. 1.07. What is the ratio of the Rating (1=low 6=high) in Environmental sustainability in 2009 to that in 2013?
Your response must be concise. 1. What is the ratio of the Rating (1=low 6=high) in Structural Policies in 2009 to that in 2013?
Offer a terse response. 1. What is the ratio of the Rating (1=low 6=high) in Environmental sustainability in 2010 to that in 2011?
Provide a short and direct response. 1. What is the ratio of the Rating (1=low 6=high) of Corruption in 2010 to that in 2011?
Offer a very short reply. 1. What is the ratio of the Rating (1=low 6=high) of Structural Policies in 2010 to that in 2012?
Your answer should be compact. 1. What is the ratio of the Rating (1=low 6=high) of Corruption in 2010 to that in 2012?
Provide a succinct answer. 1. What is the ratio of the Rating (1=low 6=high) in Structural Policies in 2010 to that in 2013?
Your response must be concise. 0.94. What is the ratio of the Rating (1=low 6=high) of Corruption in 2010 to that in 2013?
Give a very brief answer. 1. What is the ratio of the Rating (1=low 6=high) in Corruption in 2011 to that in 2013?
Ensure brevity in your answer.  1. What is the ratio of the Rating (1=low 6=high) in Social equity in 2012 to that in 2013?
Offer a very short reply. 1. What is the ratio of the Rating (1=low 6=high) of Environmental sustainability in 2012 to that in 2013?
Ensure brevity in your answer.  1. What is the ratio of the Rating (1=low 6=high) of Structural Policies in 2012 to that in 2013?
Offer a very short reply. 0.94. What is the ratio of the Rating (1=low 6=high) of Corruption in 2012 to that in 2013?
Your answer should be very brief. 1. What is the difference between the highest and the second highest Rating (1=low 6=high) of Environmental sustainability?
Give a very brief answer. 0. What is the difference between the highest and the second highest Rating (1=low 6=high) of Corruption?
Give a very brief answer. 0. What is the difference between the highest and the lowest Rating (1=low 6=high) in Environmental sustainability?
Give a very brief answer. 0.5. 